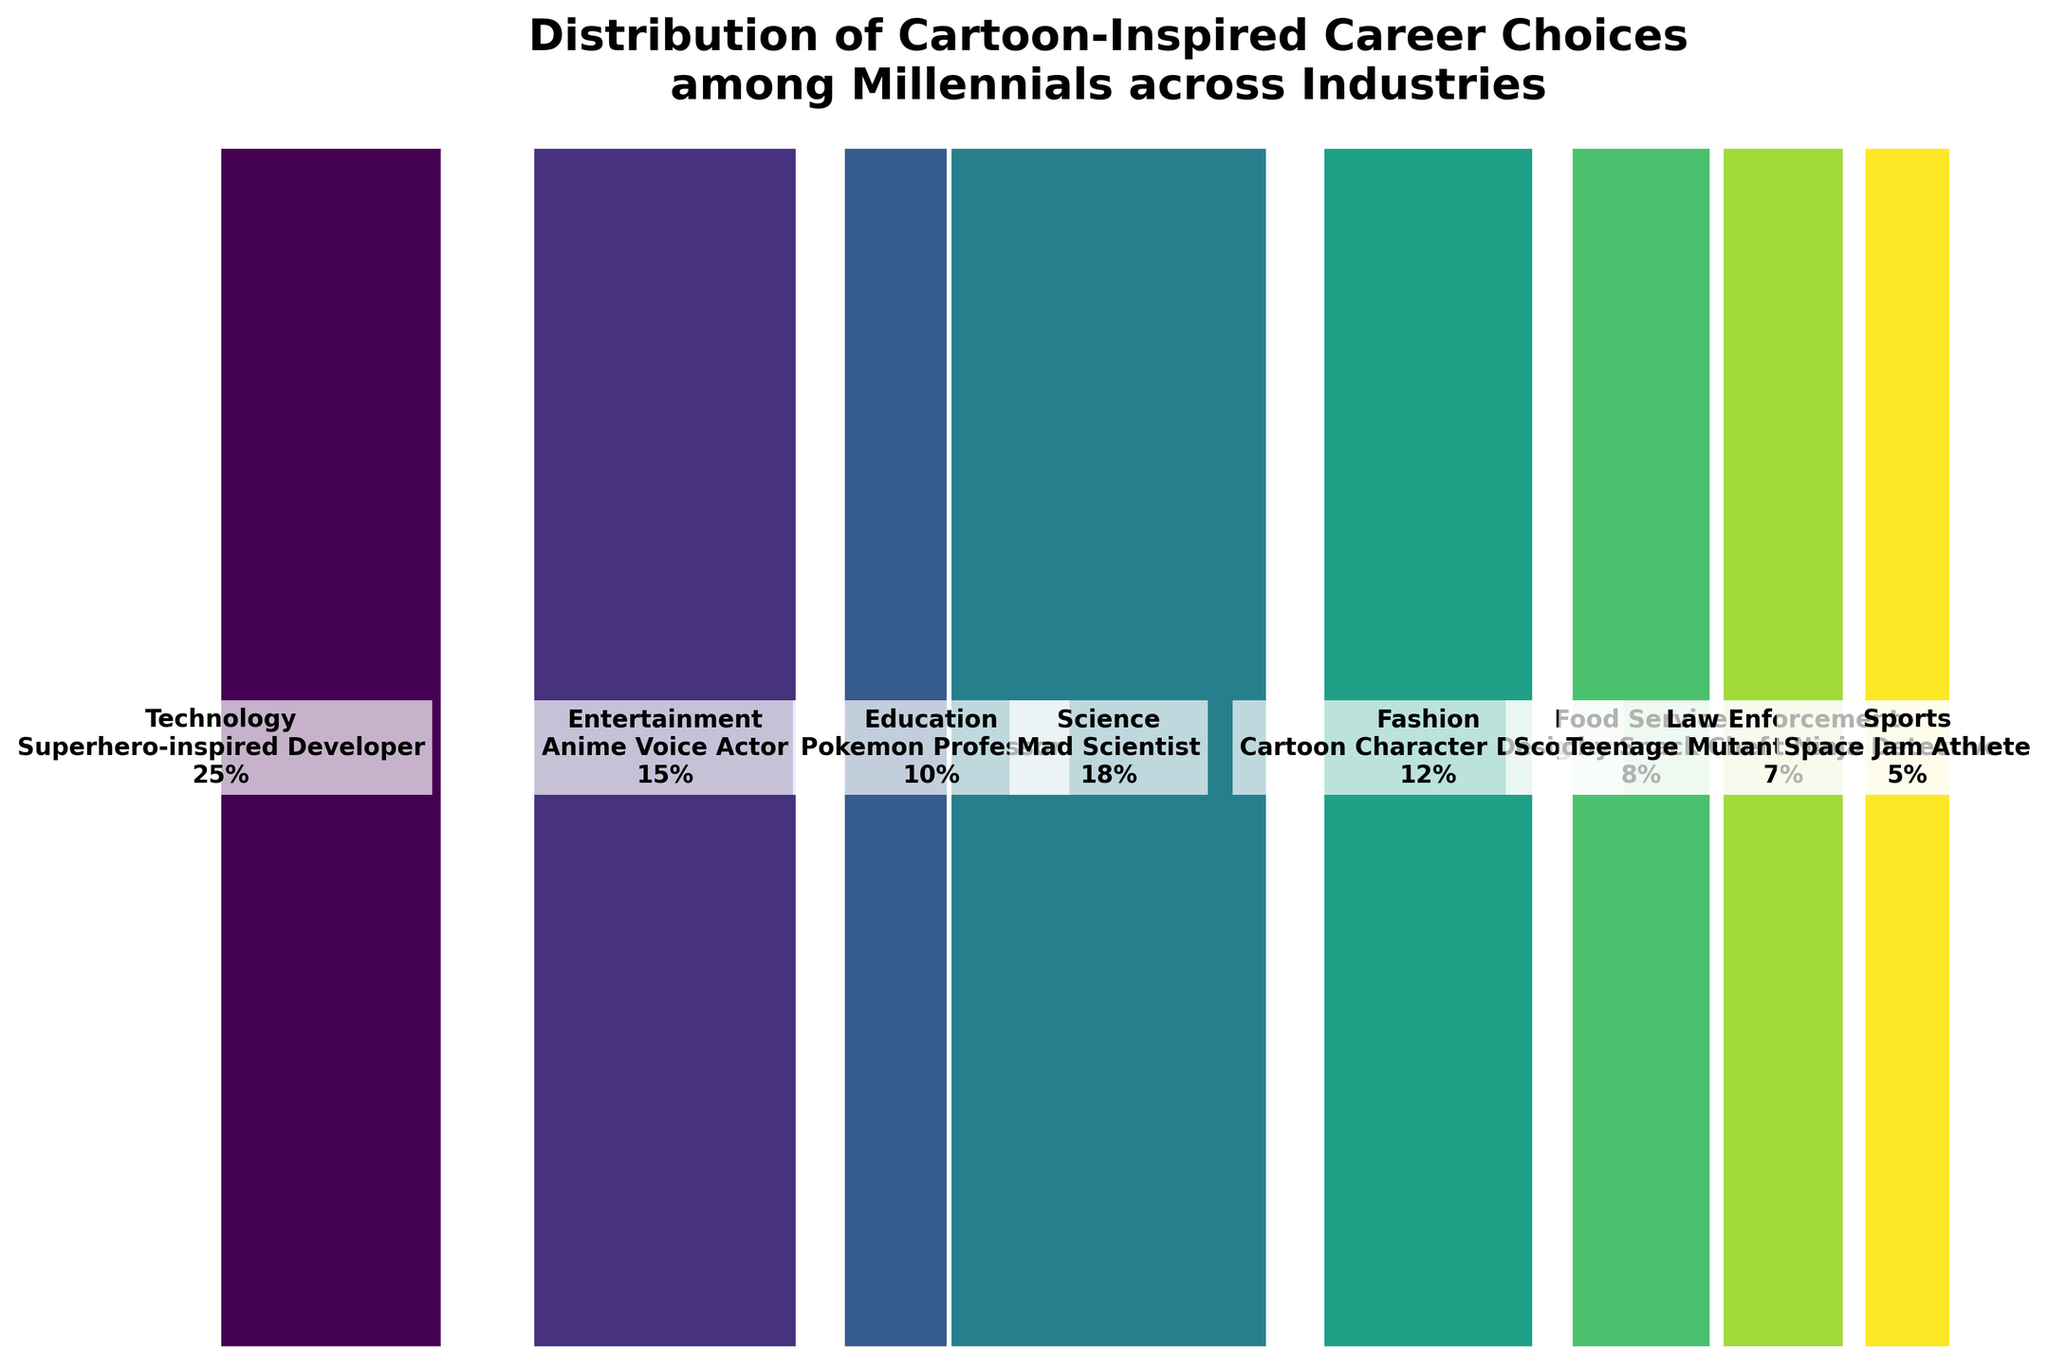What's the title of the plot? The title is located at the top of the figure and typically provides a summary of the information. Here, it's given as "Distribution of Cartoon-Inspired Career Choices among Millennials across Industries".
Answer: Distribution of Cartoon-Inspired Career Choices among Millennials across Industries What percentage of millennials chose a cartoon-inspired career in the Technology industry? The figure shows different segments representing industries. Each segment has a percentage label. For Technology, it shows "Technology\nSuperhero-inspired Developer\n25%".
Answer: 25% Which industry has the smallest percentage of cartoon-inspired career choices among millennials, and what is it? To find the smallest percentage, look for the narrowest segment and read the percentage label. The figure indicates "Sports\nSpace Jam Athlete\n5%" as the smallest.
Answer: Sports, 5% What is the combined percentage of millennials choosing careers in the Entertainment and Fashion industries? Add the percentages for Entertainment (15%) and Fashion (12%). 15% + 12% = 27%.
Answer: 27% Compare the percentages of millennials choosing careers in Food Service and Education industries. Which is higher and by how much? Subtract the percentage for Food Service (8%) from that for Education (10%). 10% - 8% = 2%. Education has a higher percentage by 2%.
Answer: Education, 2% How many industries have a cartoon-inspired career choice percentage of 10% or higher? Identify all segments with percentages 10% or higher and count them. There are Technology (25%), Entertainment (15%), Education (10%), Science (18%), and Fashion (12%), totaling 5 industries.
Answer: 5 What careers are millennials in the Technology and Science industries most inspired by? Read the career labels for Technology and Science segments. Technology shows "Superhero-inspired Developer" and Science shows "Mad Scientist".
Answer: Superhero-inspired Developer and Mad Scientist If you were to average the percentages of all the industries combined, what would that be? Calculate the mean of all the percentages: (25 + 15 + 10 + 18 + 12 + 8 + 7 + 5) / 8 = 100 / 8 = 12.5%.
Answer: 12.5% How does the percentage of millennials choosing a career in Law Enforcement compare to those in Food Service? The percentage for Law Enforcement (7%) is less than that for Food Service (8%). The difference is 8% - 7% = 1%.
Answer: Food Service, 1% Which industry has the second-highest percentage of cartoon-inspired career choices, and what is the career? Identify the segment with the second-largest width after Technology (25%). The next largest is Science (18%). The career is labeled as "Mad Scientist".
Answer: Science, Mad Scientist 